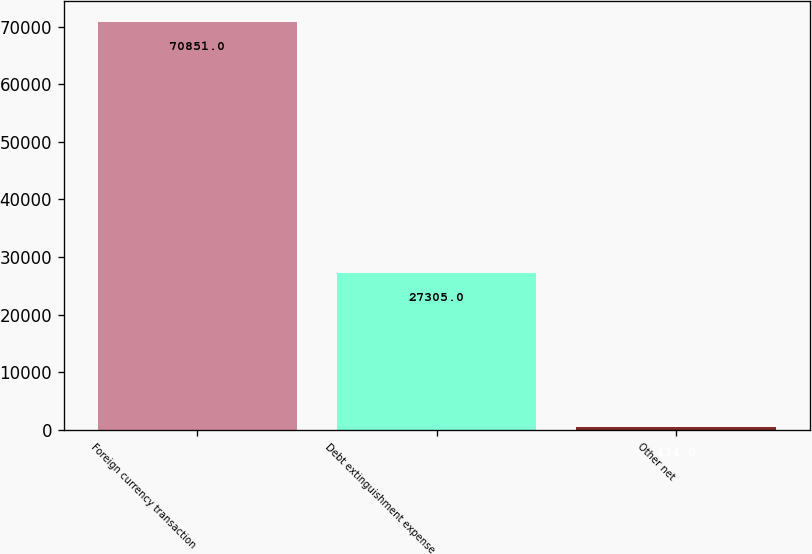Convert chart. <chart><loc_0><loc_0><loc_500><loc_500><bar_chart><fcel>Foreign currency transaction<fcel>Debt extinguishment expense<fcel>Other net<nl><fcel>70851<fcel>27305<fcel>434<nl></chart> 